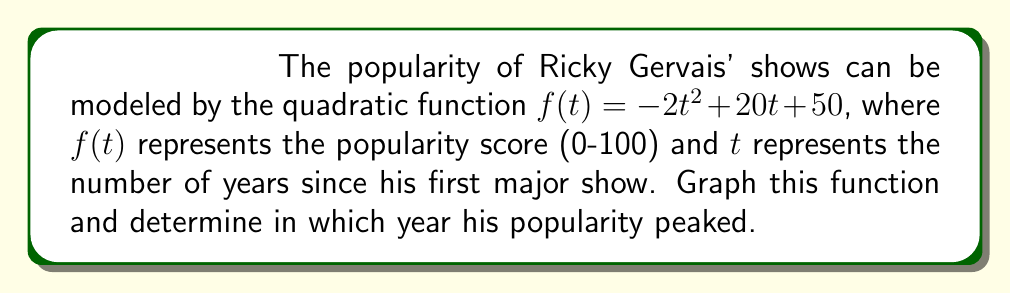Teach me how to tackle this problem. 1) To graph the quadratic function $f(t) = -2t^2 + 20t + 50$, we need to find its key features:

2) The axis of symmetry: $t = -b/(2a) = -20/(-4) = 5$ years

3) The vertex: $(5, f(5))$
   $f(5) = -2(5)^2 + 20(5) + 50 = -50 + 100 + 50 = 100$
   So the vertex is $(5, 100)$

4) y-intercept: When $t=0$, $f(0) = 50$

5) x-intercepts: 
   $0 = -2t^2 + 20t + 50$
   $2t^2 - 20t - 50 = 0$
   Using the quadratic formula: $t = \frac{20 \pm \sqrt{400 + 400}}{4} = \frac{20 \pm \sqrt{800}}{4}$
   $t \approx 12.4$ or $t \approx -2.4$

6) Plot these points and sketch the parabola:

[asy]
import graph;
size(200,200);
real f(real x) {return -2x^2+20x+50;}
xaxis("t (years)",Ticks());
yaxis("Popularity",Ticks());
draw(graph(f,-2,12));
dot((0,50));
dot((5,100));
dot((12.4,0));
label("(5,100)",(5,100),NE);
label("(0,50)",(0,50),SW);
[/asy]

7) The peak of the parabola is at the vertex $(5, 100)$. Since $t$ represents years since his first major show, his popularity peaked 5 years after his first major show.
Answer: 5 years after his first major show 